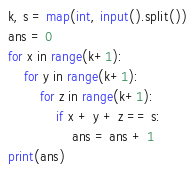Convert code to text. <code><loc_0><loc_0><loc_500><loc_500><_Python_>k, s = map(int, input().split())
ans = 0
for x in range(k+1):
    for y in range(k+1):
        for z in range(k+1):
            if x + y + z == s:
                ans = ans + 1
print(ans)</code> 